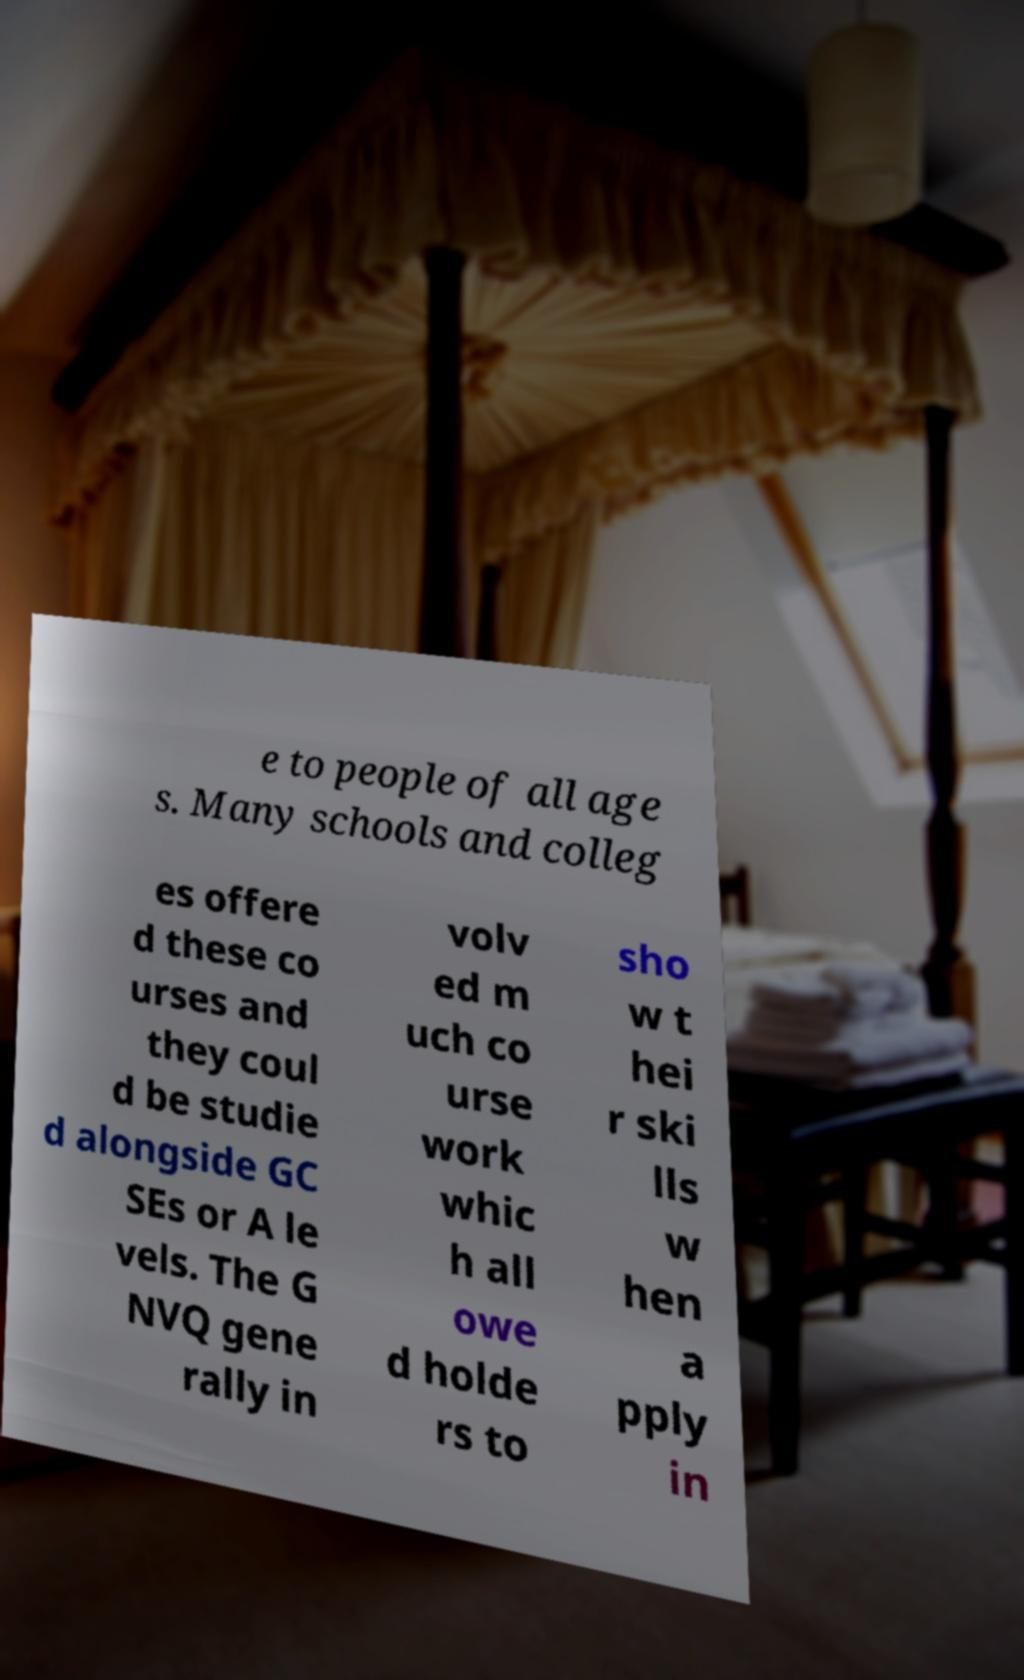Can you read and provide the text displayed in the image?This photo seems to have some interesting text. Can you extract and type it out for me? e to people of all age s. Many schools and colleg es offere d these co urses and they coul d be studie d alongside GC SEs or A le vels. The G NVQ gene rally in volv ed m uch co urse work whic h all owe d holde rs to sho w t hei r ski lls w hen a pply in 